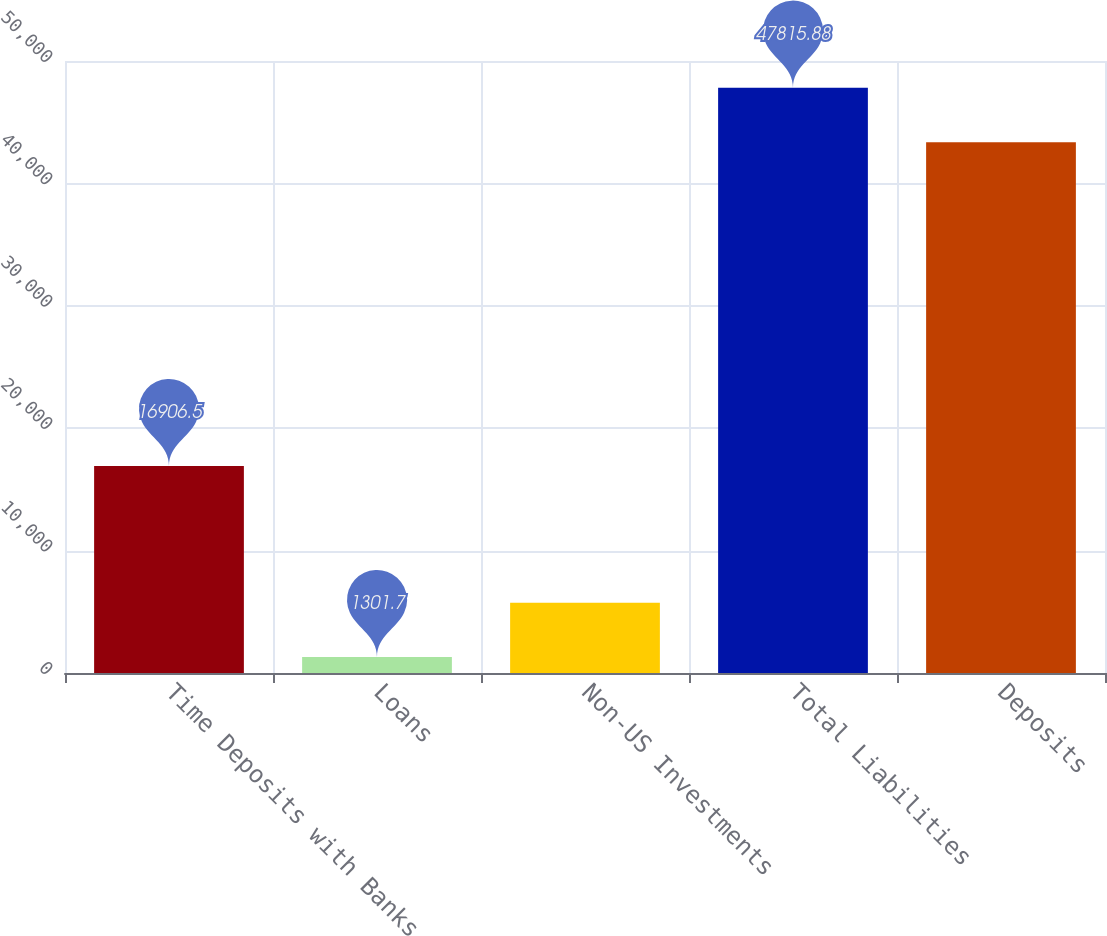<chart> <loc_0><loc_0><loc_500><loc_500><bar_chart><fcel>Time Deposits with Banks<fcel>Loans<fcel>Non-US Investments<fcel>Total Liabilities<fcel>Deposits<nl><fcel>16906.5<fcel>1301.7<fcel>5747.28<fcel>47815.9<fcel>43370.3<nl></chart> 